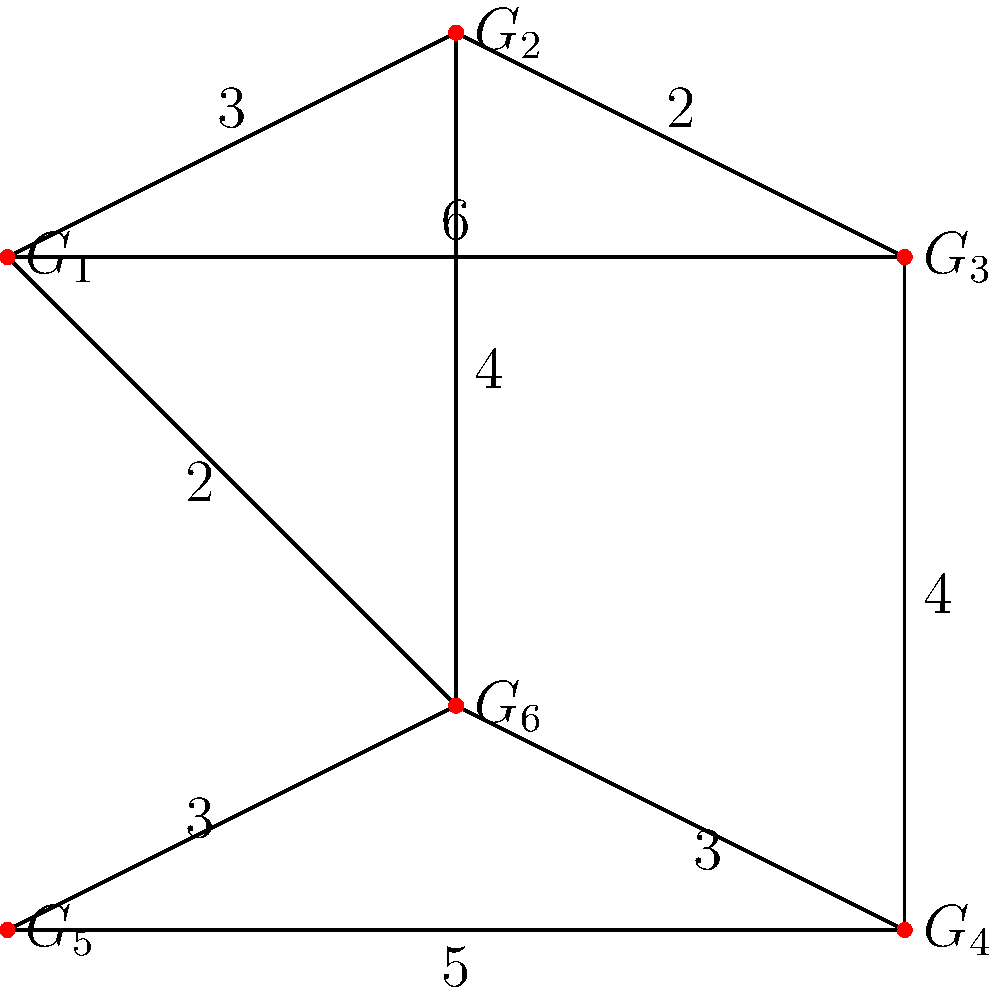In a network of support groups for bereaved individuals, each group is represented by a node ($G_1$ to $G_6$), and the connections between groups are represented by edges with weights indicating the emotional distance between groups. What is the shortest emotional path from group $G_1$ to group $G_4$, and what is its total emotional distance? To find the shortest emotional path from $G_1$ to $G_4$, we need to use Dijkstra's algorithm or a similar shortest path algorithm. Let's go through the process step-by-step:

1) Start at $G_1$ and consider all its neighbors:
   - $G_1$ to $G_2$: distance 3
   - $G_1$ to $G_3$: distance 6
   - $G_1$ to $G_6$: distance 2

2) The shortest path so far is to $G_6$ with distance 2. Mark $G_6$ as visited.

3) From $G_6$, consider its unvisited neighbors:
   - $G_6$ to $G_2$: total distance 2 + 4 = 6
   - $G_6$ to $G_4$: total distance 2 + 3 = 5
   - $G_6$ to $G_5$: total distance 2 + 3 = 5

4) The shortest path is now to $G_4$ or $G_5$, both with distance 5. We've reached $G_4$, so we can stop.

Therefore, the shortest emotional path from $G_1$ to $G_4$ is $G_1 \rightarrow G_6 \rightarrow G_4$ with a total emotional distance of 5.
Answer: $G_1 \rightarrow G_6 \rightarrow G_4$, distance 5 